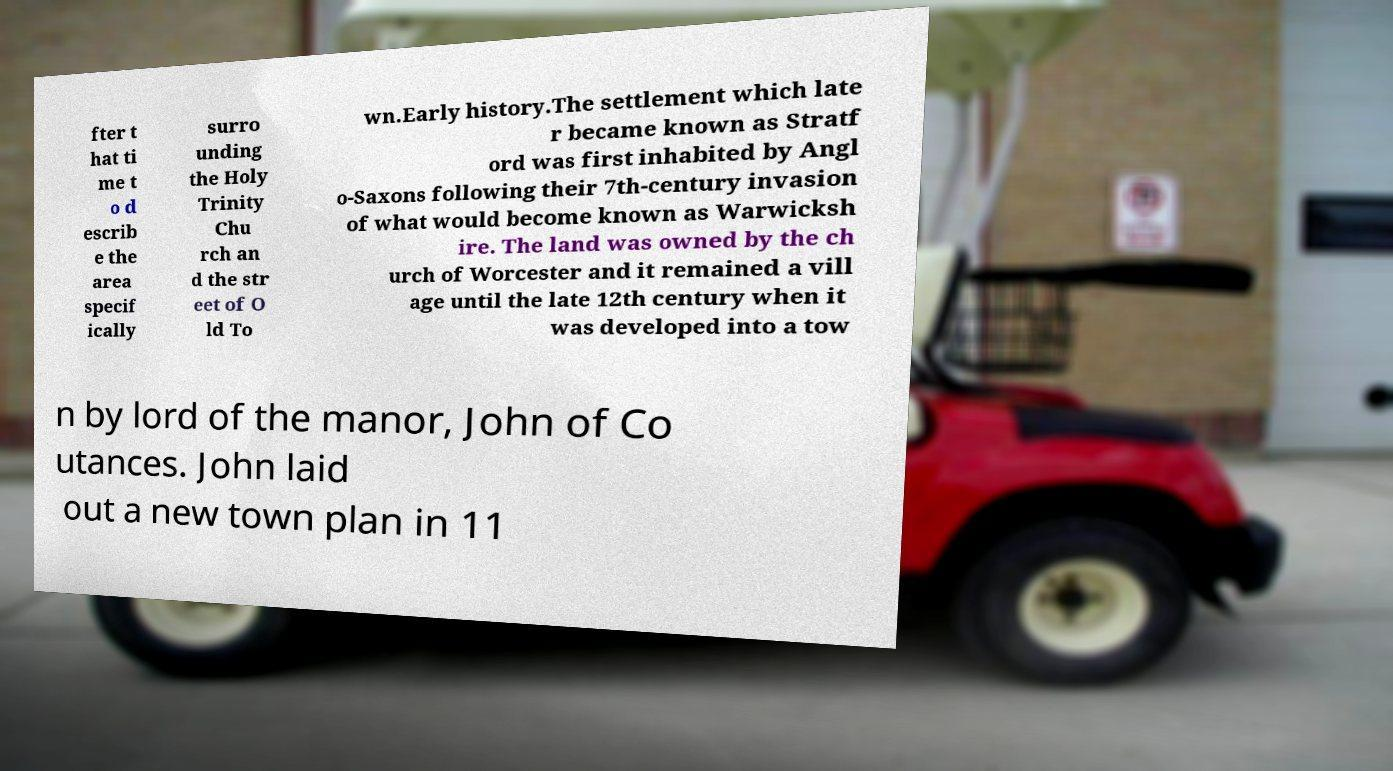Please identify and transcribe the text found in this image. fter t hat ti me t o d escrib e the area specif ically surro unding the Holy Trinity Chu rch an d the str eet of O ld To wn.Early history.The settlement which late r became known as Stratf ord was first inhabited by Angl o-Saxons following their 7th-century invasion of what would become known as Warwicksh ire. The land was owned by the ch urch of Worcester and it remained a vill age until the late 12th century when it was developed into a tow n by lord of the manor, John of Co utances. John laid out a new town plan in 11 